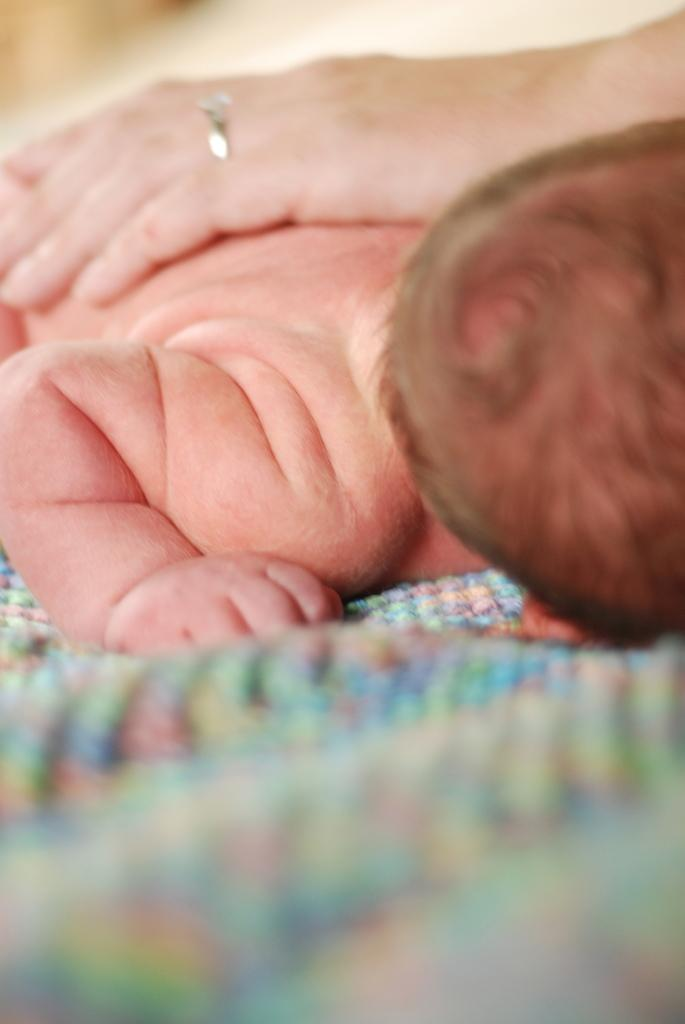What is the main subject of the image? The main subject of the image is a kid. What is the kid doing in the image? The kid is sleeping on a mat. Can you describe anything else in the image besides the kid? Yes, there is a hand with a ring on a finger above the kid. What type of snow can be seen falling on the kid in the image? There is no snow present in the image; it features a kid sleeping on a mat with a hand above them. Can you tell me how many goats are visible in the image? There are no goats present in the image. 